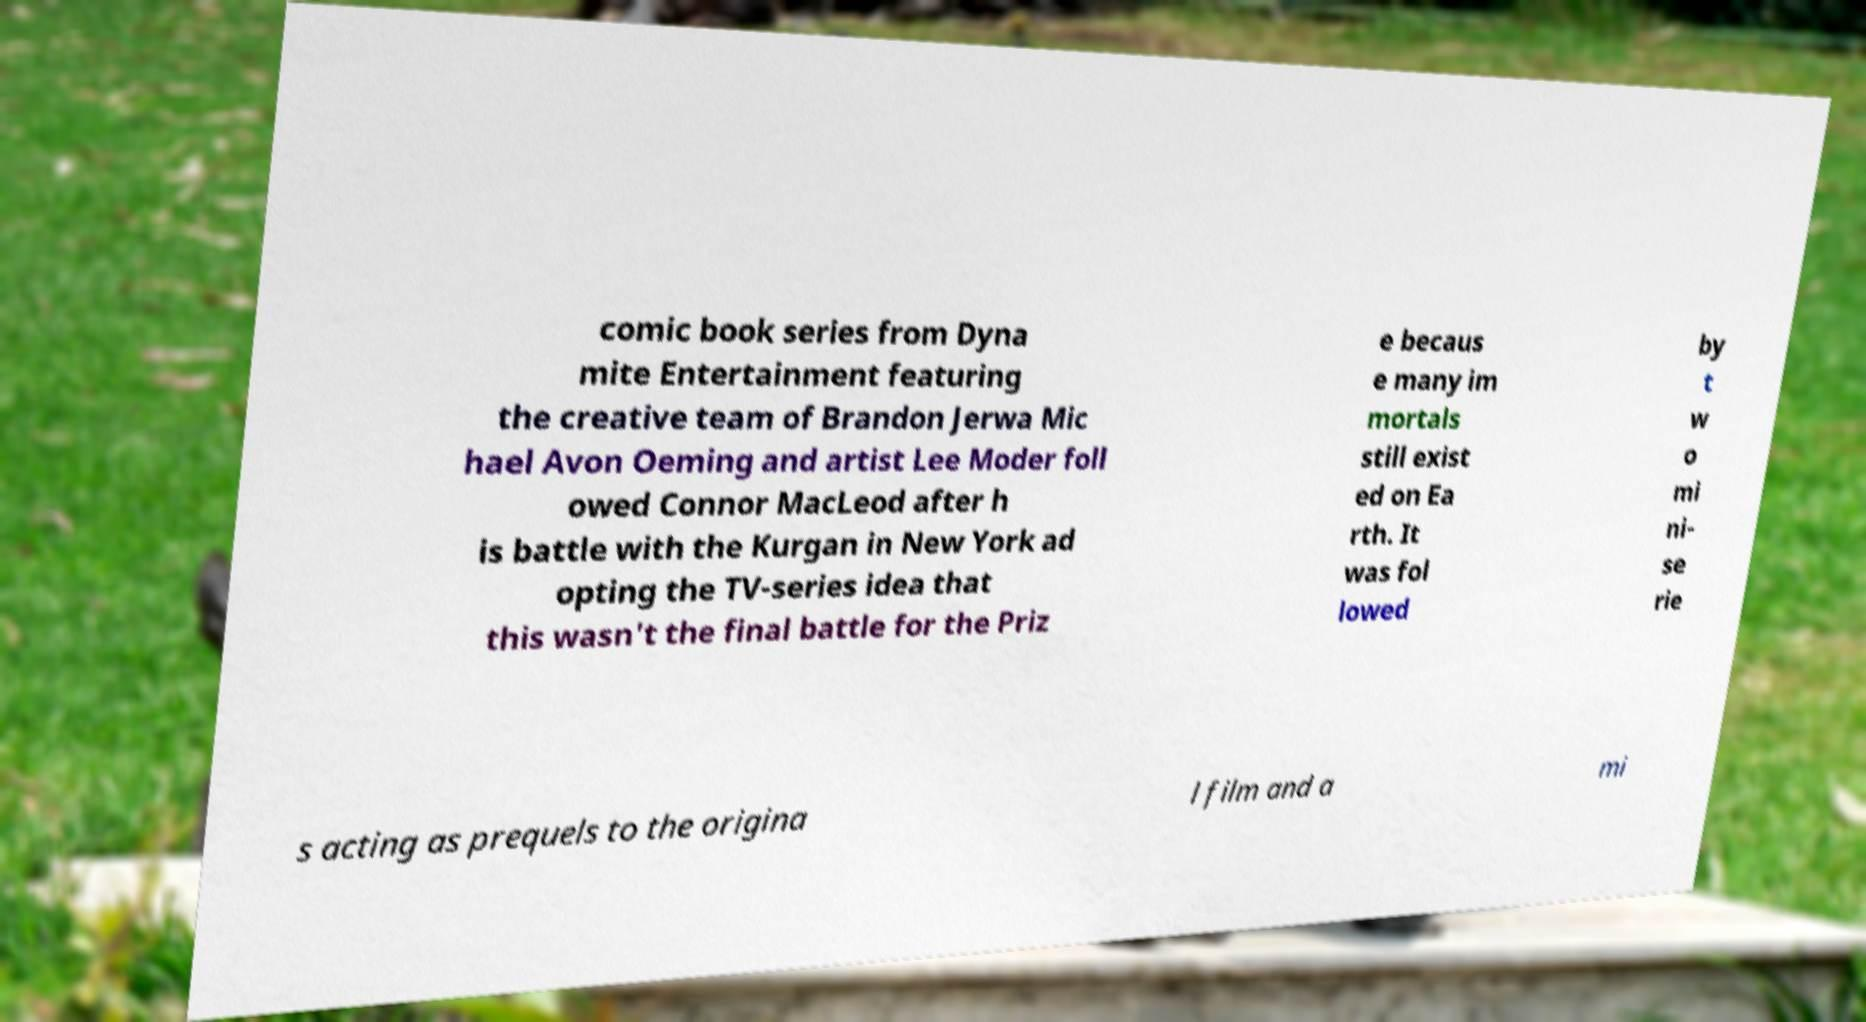Could you assist in decoding the text presented in this image and type it out clearly? comic book series from Dyna mite Entertainment featuring the creative team of Brandon Jerwa Mic hael Avon Oeming and artist Lee Moder foll owed Connor MacLeod after h is battle with the Kurgan in New York ad opting the TV-series idea that this wasn't the final battle for the Priz e becaus e many im mortals still exist ed on Ea rth. It was fol lowed by t w o mi ni- se rie s acting as prequels to the origina l film and a mi 